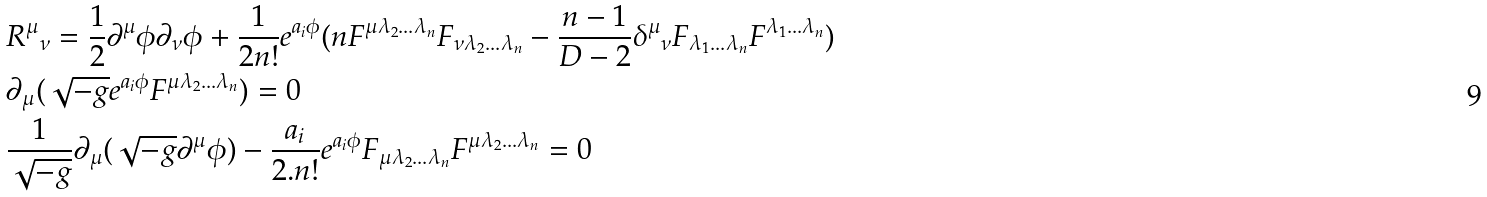<formula> <loc_0><loc_0><loc_500><loc_500>& { R ^ { \mu } } _ { \nu } = \frac { 1 } { 2 } \partial ^ { \mu } \phi \partial _ { \nu } \phi + \frac { 1 } { 2 n ! } e ^ { a _ { i } \phi } ( n F ^ { \mu \lambda _ { 2 } \dots \lambda _ { n } } F _ { \nu \lambda _ { 2 } \dots \lambda _ { n } } - \frac { n - 1 } { D - 2 } { \delta ^ { \mu } } _ { \nu } F _ { \lambda _ { 1 } \dots \lambda _ { n } } F ^ { \lambda _ { 1 } \dots \lambda _ { n } } ) \\ & \partial _ { \mu } ( \sqrt { - g } e ^ { a _ { i } \phi } F ^ { \mu \lambda _ { 2 } \dots \lambda _ { n } } ) = 0 \\ & \frac { 1 } { \sqrt { - g } } \partial _ { \mu } ( \sqrt { - g } \partial ^ { \mu } \phi ) - \frac { a _ { i } } { 2 . n ! } e ^ { a _ { i } \phi } F _ { \mu \lambda _ { 2 } \dots \lambda _ { n } } F ^ { \mu \lambda _ { 2 } \dots \lambda _ { n } } = 0</formula> 